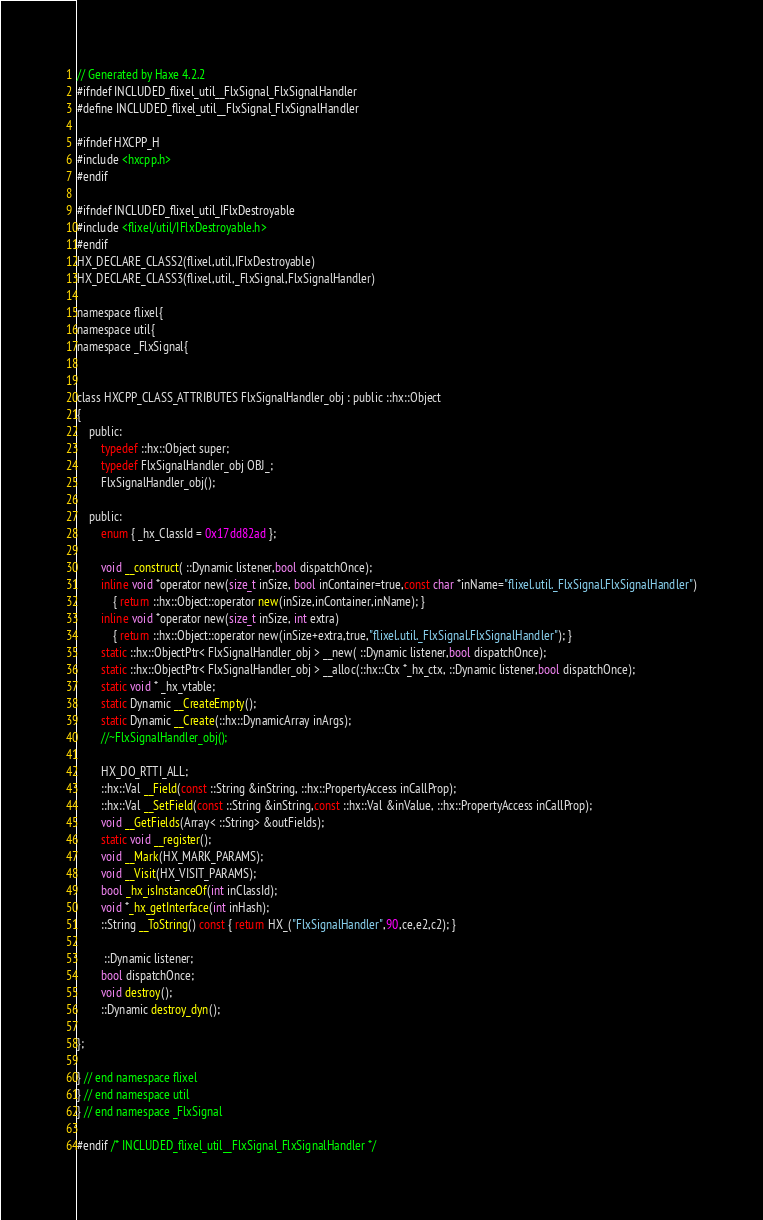<code> <loc_0><loc_0><loc_500><loc_500><_C_>// Generated by Haxe 4.2.2
#ifndef INCLUDED_flixel_util__FlxSignal_FlxSignalHandler
#define INCLUDED_flixel_util__FlxSignal_FlxSignalHandler

#ifndef HXCPP_H
#include <hxcpp.h>
#endif

#ifndef INCLUDED_flixel_util_IFlxDestroyable
#include <flixel/util/IFlxDestroyable.h>
#endif
HX_DECLARE_CLASS2(flixel,util,IFlxDestroyable)
HX_DECLARE_CLASS3(flixel,util,_FlxSignal,FlxSignalHandler)

namespace flixel{
namespace util{
namespace _FlxSignal{


class HXCPP_CLASS_ATTRIBUTES FlxSignalHandler_obj : public ::hx::Object
{
	public:
		typedef ::hx::Object super;
		typedef FlxSignalHandler_obj OBJ_;
		FlxSignalHandler_obj();

	public:
		enum { _hx_ClassId = 0x17dd82ad };

		void __construct( ::Dynamic listener,bool dispatchOnce);
		inline void *operator new(size_t inSize, bool inContainer=true,const char *inName="flixel.util._FlxSignal.FlxSignalHandler")
			{ return ::hx::Object::operator new(inSize,inContainer,inName); }
		inline void *operator new(size_t inSize, int extra)
			{ return ::hx::Object::operator new(inSize+extra,true,"flixel.util._FlxSignal.FlxSignalHandler"); }
		static ::hx::ObjectPtr< FlxSignalHandler_obj > __new( ::Dynamic listener,bool dispatchOnce);
		static ::hx::ObjectPtr< FlxSignalHandler_obj > __alloc(::hx::Ctx *_hx_ctx, ::Dynamic listener,bool dispatchOnce);
		static void * _hx_vtable;
		static Dynamic __CreateEmpty();
		static Dynamic __Create(::hx::DynamicArray inArgs);
		//~FlxSignalHandler_obj();

		HX_DO_RTTI_ALL;
		::hx::Val __Field(const ::String &inString, ::hx::PropertyAccess inCallProp);
		::hx::Val __SetField(const ::String &inString,const ::hx::Val &inValue, ::hx::PropertyAccess inCallProp);
		void __GetFields(Array< ::String> &outFields);
		static void __register();
		void __Mark(HX_MARK_PARAMS);
		void __Visit(HX_VISIT_PARAMS);
		bool _hx_isInstanceOf(int inClassId);
		void *_hx_getInterface(int inHash);
		::String __ToString() const { return HX_("FlxSignalHandler",90,ce,e2,c2); }

		 ::Dynamic listener;
		bool dispatchOnce;
		void destroy();
		::Dynamic destroy_dyn();

};

} // end namespace flixel
} // end namespace util
} // end namespace _FlxSignal

#endif /* INCLUDED_flixel_util__FlxSignal_FlxSignalHandler */ 
</code> 